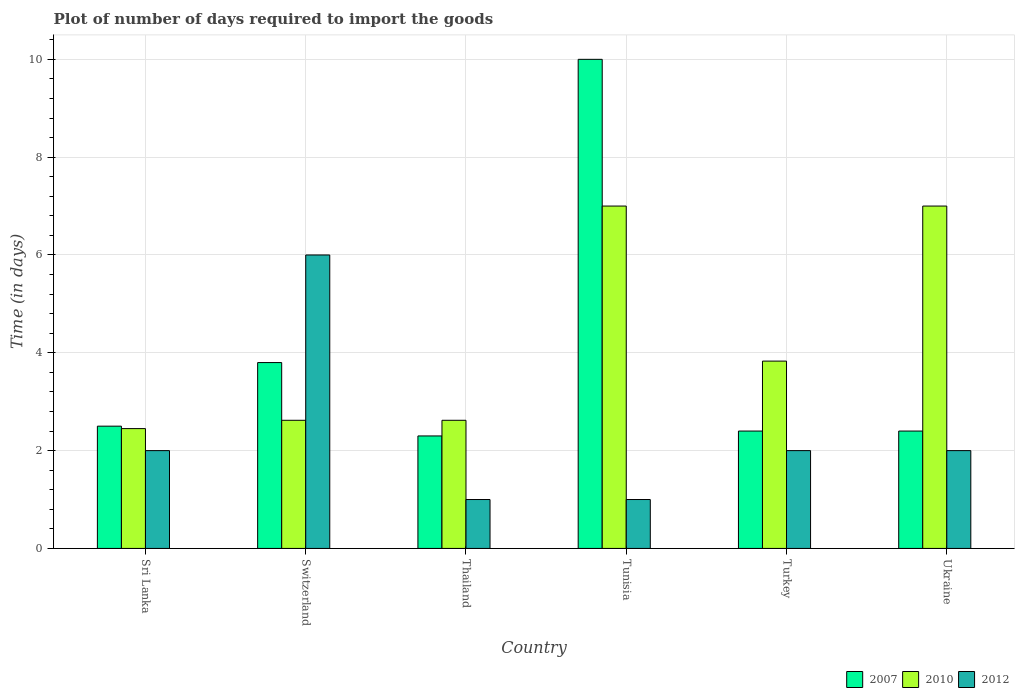How many groups of bars are there?
Provide a short and direct response. 6. Are the number of bars per tick equal to the number of legend labels?
Make the answer very short. Yes. Are the number of bars on each tick of the X-axis equal?
Provide a short and direct response. Yes. How many bars are there on the 3rd tick from the left?
Provide a succinct answer. 3. What is the label of the 6th group of bars from the left?
Make the answer very short. Ukraine. What is the time required to import goods in 2007 in Tunisia?
Your answer should be very brief. 10. Across all countries, what is the maximum time required to import goods in 2012?
Provide a short and direct response. 6. In which country was the time required to import goods in 2007 maximum?
Provide a short and direct response. Tunisia. In which country was the time required to import goods in 2012 minimum?
Give a very brief answer. Thailand. What is the total time required to import goods in 2007 in the graph?
Offer a very short reply. 23.4. What is the difference between the time required to import goods in 2010 in Sri Lanka and that in Tunisia?
Provide a short and direct response. -4.55. What is the difference between the time required to import goods in 2007 in Switzerland and the time required to import goods in 2010 in Thailand?
Provide a succinct answer. 1.18. What is the average time required to import goods in 2007 per country?
Keep it short and to the point. 3.9. What is the ratio of the time required to import goods in 2010 in Turkey to that in Ukraine?
Offer a very short reply. 0.55. Is the difference between the time required to import goods in 2012 in Sri Lanka and Thailand greater than the difference between the time required to import goods in 2007 in Sri Lanka and Thailand?
Give a very brief answer. Yes. What is the difference between the highest and the lowest time required to import goods in 2012?
Make the answer very short. 5. What does the 1st bar from the left in Tunisia represents?
Make the answer very short. 2007. What does the 2nd bar from the right in Thailand represents?
Your response must be concise. 2010. Is it the case that in every country, the sum of the time required to import goods in 2007 and time required to import goods in 2012 is greater than the time required to import goods in 2010?
Provide a short and direct response. No. How many bars are there?
Provide a short and direct response. 18. Are all the bars in the graph horizontal?
Your answer should be compact. No. How many countries are there in the graph?
Offer a terse response. 6. What is the difference between two consecutive major ticks on the Y-axis?
Provide a succinct answer. 2. Does the graph contain any zero values?
Your response must be concise. No. How many legend labels are there?
Your response must be concise. 3. What is the title of the graph?
Your answer should be very brief. Plot of number of days required to import the goods. Does "2006" appear as one of the legend labels in the graph?
Offer a very short reply. No. What is the label or title of the Y-axis?
Keep it short and to the point. Time (in days). What is the Time (in days) in 2007 in Sri Lanka?
Offer a terse response. 2.5. What is the Time (in days) in 2010 in Sri Lanka?
Give a very brief answer. 2.45. What is the Time (in days) in 2010 in Switzerland?
Offer a very short reply. 2.62. What is the Time (in days) in 2012 in Switzerland?
Make the answer very short. 6. What is the Time (in days) of 2007 in Thailand?
Give a very brief answer. 2.3. What is the Time (in days) of 2010 in Thailand?
Offer a very short reply. 2.62. What is the Time (in days) in 2012 in Tunisia?
Provide a short and direct response. 1. What is the Time (in days) in 2010 in Turkey?
Ensure brevity in your answer.  3.83. What is the Time (in days) of 2010 in Ukraine?
Offer a terse response. 7. What is the Time (in days) in 2012 in Ukraine?
Your response must be concise. 2. Across all countries, what is the maximum Time (in days) of 2007?
Offer a terse response. 10. Across all countries, what is the maximum Time (in days) of 2010?
Provide a succinct answer. 7. Across all countries, what is the minimum Time (in days) in 2010?
Your answer should be very brief. 2.45. Across all countries, what is the minimum Time (in days) in 2012?
Your answer should be compact. 1. What is the total Time (in days) of 2007 in the graph?
Ensure brevity in your answer.  23.4. What is the total Time (in days) of 2010 in the graph?
Your answer should be compact. 25.52. What is the difference between the Time (in days) of 2010 in Sri Lanka and that in Switzerland?
Make the answer very short. -0.17. What is the difference between the Time (in days) in 2012 in Sri Lanka and that in Switzerland?
Your response must be concise. -4. What is the difference between the Time (in days) in 2010 in Sri Lanka and that in Thailand?
Make the answer very short. -0.17. What is the difference between the Time (in days) in 2012 in Sri Lanka and that in Thailand?
Give a very brief answer. 1. What is the difference between the Time (in days) in 2010 in Sri Lanka and that in Tunisia?
Keep it short and to the point. -4.55. What is the difference between the Time (in days) in 2012 in Sri Lanka and that in Tunisia?
Make the answer very short. 1. What is the difference between the Time (in days) in 2010 in Sri Lanka and that in Turkey?
Ensure brevity in your answer.  -1.38. What is the difference between the Time (in days) in 2012 in Sri Lanka and that in Turkey?
Make the answer very short. 0. What is the difference between the Time (in days) of 2010 in Sri Lanka and that in Ukraine?
Provide a succinct answer. -4.55. What is the difference between the Time (in days) of 2007 in Switzerland and that in Thailand?
Make the answer very short. 1.5. What is the difference between the Time (in days) in 2010 in Switzerland and that in Thailand?
Make the answer very short. 0. What is the difference between the Time (in days) in 2010 in Switzerland and that in Tunisia?
Ensure brevity in your answer.  -4.38. What is the difference between the Time (in days) in 2012 in Switzerland and that in Tunisia?
Offer a very short reply. 5. What is the difference between the Time (in days) of 2007 in Switzerland and that in Turkey?
Your answer should be compact. 1.4. What is the difference between the Time (in days) in 2010 in Switzerland and that in Turkey?
Provide a short and direct response. -1.21. What is the difference between the Time (in days) in 2012 in Switzerland and that in Turkey?
Offer a very short reply. 4. What is the difference between the Time (in days) of 2007 in Switzerland and that in Ukraine?
Provide a succinct answer. 1.4. What is the difference between the Time (in days) in 2010 in Switzerland and that in Ukraine?
Make the answer very short. -4.38. What is the difference between the Time (in days) of 2012 in Switzerland and that in Ukraine?
Offer a terse response. 4. What is the difference between the Time (in days) in 2010 in Thailand and that in Tunisia?
Your answer should be compact. -4.38. What is the difference between the Time (in days) of 2012 in Thailand and that in Tunisia?
Make the answer very short. 0. What is the difference between the Time (in days) in 2010 in Thailand and that in Turkey?
Keep it short and to the point. -1.21. What is the difference between the Time (in days) in 2012 in Thailand and that in Turkey?
Offer a terse response. -1. What is the difference between the Time (in days) of 2010 in Thailand and that in Ukraine?
Make the answer very short. -4.38. What is the difference between the Time (in days) of 2012 in Thailand and that in Ukraine?
Provide a short and direct response. -1. What is the difference between the Time (in days) in 2007 in Tunisia and that in Turkey?
Make the answer very short. 7.6. What is the difference between the Time (in days) of 2010 in Tunisia and that in Turkey?
Provide a succinct answer. 3.17. What is the difference between the Time (in days) in 2012 in Tunisia and that in Turkey?
Keep it short and to the point. -1. What is the difference between the Time (in days) of 2007 in Tunisia and that in Ukraine?
Provide a short and direct response. 7.6. What is the difference between the Time (in days) of 2007 in Turkey and that in Ukraine?
Your response must be concise. 0. What is the difference between the Time (in days) in 2010 in Turkey and that in Ukraine?
Provide a succinct answer. -3.17. What is the difference between the Time (in days) in 2012 in Turkey and that in Ukraine?
Offer a terse response. 0. What is the difference between the Time (in days) of 2007 in Sri Lanka and the Time (in days) of 2010 in Switzerland?
Make the answer very short. -0.12. What is the difference between the Time (in days) of 2010 in Sri Lanka and the Time (in days) of 2012 in Switzerland?
Your response must be concise. -3.55. What is the difference between the Time (in days) in 2007 in Sri Lanka and the Time (in days) in 2010 in Thailand?
Provide a succinct answer. -0.12. What is the difference between the Time (in days) in 2007 in Sri Lanka and the Time (in days) in 2012 in Thailand?
Provide a short and direct response. 1.5. What is the difference between the Time (in days) in 2010 in Sri Lanka and the Time (in days) in 2012 in Thailand?
Make the answer very short. 1.45. What is the difference between the Time (in days) in 2007 in Sri Lanka and the Time (in days) in 2012 in Tunisia?
Your answer should be compact. 1.5. What is the difference between the Time (in days) in 2010 in Sri Lanka and the Time (in days) in 2012 in Tunisia?
Keep it short and to the point. 1.45. What is the difference between the Time (in days) in 2007 in Sri Lanka and the Time (in days) in 2010 in Turkey?
Your answer should be compact. -1.33. What is the difference between the Time (in days) of 2007 in Sri Lanka and the Time (in days) of 2012 in Turkey?
Your answer should be very brief. 0.5. What is the difference between the Time (in days) in 2010 in Sri Lanka and the Time (in days) in 2012 in Turkey?
Offer a terse response. 0.45. What is the difference between the Time (in days) of 2010 in Sri Lanka and the Time (in days) of 2012 in Ukraine?
Your answer should be compact. 0.45. What is the difference between the Time (in days) of 2007 in Switzerland and the Time (in days) of 2010 in Thailand?
Make the answer very short. 1.18. What is the difference between the Time (in days) in 2010 in Switzerland and the Time (in days) in 2012 in Thailand?
Keep it short and to the point. 1.62. What is the difference between the Time (in days) of 2007 in Switzerland and the Time (in days) of 2012 in Tunisia?
Offer a terse response. 2.8. What is the difference between the Time (in days) in 2010 in Switzerland and the Time (in days) in 2012 in Tunisia?
Give a very brief answer. 1.62. What is the difference between the Time (in days) of 2007 in Switzerland and the Time (in days) of 2010 in Turkey?
Provide a short and direct response. -0.03. What is the difference between the Time (in days) in 2007 in Switzerland and the Time (in days) in 2012 in Turkey?
Provide a short and direct response. 1.8. What is the difference between the Time (in days) of 2010 in Switzerland and the Time (in days) of 2012 in Turkey?
Offer a very short reply. 0.62. What is the difference between the Time (in days) in 2007 in Switzerland and the Time (in days) in 2010 in Ukraine?
Your answer should be compact. -3.2. What is the difference between the Time (in days) in 2007 in Switzerland and the Time (in days) in 2012 in Ukraine?
Offer a very short reply. 1.8. What is the difference between the Time (in days) of 2010 in Switzerland and the Time (in days) of 2012 in Ukraine?
Make the answer very short. 0.62. What is the difference between the Time (in days) in 2007 in Thailand and the Time (in days) in 2012 in Tunisia?
Offer a very short reply. 1.3. What is the difference between the Time (in days) of 2010 in Thailand and the Time (in days) of 2012 in Tunisia?
Provide a succinct answer. 1.62. What is the difference between the Time (in days) in 2007 in Thailand and the Time (in days) in 2010 in Turkey?
Give a very brief answer. -1.53. What is the difference between the Time (in days) in 2010 in Thailand and the Time (in days) in 2012 in Turkey?
Your response must be concise. 0.62. What is the difference between the Time (in days) in 2007 in Thailand and the Time (in days) in 2012 in Ukraine?
Make the answer very short. 0.3. What is the difference between the Time (in days) of 2010 in Thailand and the Time (in days) of 2012 in Ukraine?
Give a very brief answer. 0.62. What is the difference between the Time (in days) of 2007 in Tunisia and the Time (in days) of 2010 in Turkey?
Your response must be concise. 6.17. What is the difference between the Time (in days) of 2007 in Tunisia and the Time (in days) of 2012 in Turkey?
Offer a very short reply. 8. What is the difference between the Time (in days) in 2007 in Tunisia and the Time (in days) in 2010 in Ukraine?
Your answer should be very brief. 3. What is the difference between the Time (in days) in 2007 in Tunisia and the Time (in days) in 2012 in Ukraine?
Give a very brief answer. 8. What is the difference between the Time (in days) of 2010 in Tunisia and the Time (in days) of 2012 in Ukraine?
Keep it short and to the point. 5. What is the difference between the Time (in days) in 2007 in Turkey and the Time (in days) in 2010 in Ukraine?
Provide a succinct answer. -4.6. What is the difference between the Time (in days) in 2007 in Turkey and the Time (in days) in 2012 in Ukraine?
Your answer should be very brief. 0.4. What is the difference between the Time (in days) of 2010 in Turkey and the Time (in days) of 2012 in Ukraine?
Provide a short and direct response. 1.83. What is the average Time (in days) of 2010 per country?
Your response must be concise. 4.25. What is the average Time (in days) of 2012 per country?
Provide a short and direct response. 2.33. What is the difference between the Time (in days) in 2010 and Time (in days) in 2012 in Sri Lanka?
Ensure brevity in your answer.  0.45. What is the difference between the Time (in days) in 2007 and Time (in days) in 2010 in Switzerland?
Offer a very short reply. 1.18. What is the difference between the Time (in days) in 2010 and Time (in days) in 2012 in Switzerland?
Ensure brevity in your answer.  -3.38. What is the difference between the Time (in days) in 2007 and Time (in days) in 2010 in Thailand?
Make the answer very short. -0.32. What is the difference between the Time (in days) in 2007 and Time (in days) in 2012 in Thailand?
Your response must be concise. 1.3. What is the difference between the Time (in days) in 2010 and Time (in days) in 2012 in Thailand?
Offer a terse response. 1.62. What is the difference between the Time (in days) of 2010 and Time (in days) of 2012 in Tunisia?
Offer a terse response. 6. What is the difference between the Time (in days) in 2007 and Time (in days) in 2010 in Turkey?
Give a very brief answer. -1.43. What is the difference between the Time (in days) in 2010 and Time (in days) in 2012 in Turkey?
Your answer should be very brief. 1.83. What is the difference between the Time (in days) in 2007 and Time (in days) in 2010 in Ukraine?
Provide a succinct answer. -4.6. What is the ratio of the Time (in days) of 2007 in Sri Lanka to that in Switzerland?
Your answer should be very brief. 0.66. What is the ratio of the Time (in days) of 2010 in Sri Lanka to that in Switzerland?
Make the answer very short. 0.94. What is the ratio of the Time (in days) of 2012 in Sri Lanka to that in Switzerland?
Keep it short and to the point. 0.33. What is the ratio of the Time (in days) in 2007 in Sri Lanka to that in Thailand?
Offer a terse response. 1.09. What is the ratio of the Time (in days) in 2010 in Sri Lanka to that in Thailand?
Provide a short and direct response. 0.94. What is the ratio of the Time (in days) of 2012 in Sri Lanka to that in Thailand?
Provide a short and direct response. 2. What is the ratio of the Time (in days) of 2007 in Sri Lanka to that in Tunisia?
Provide a short and direct response. 0.25. What is the ratio of the Time (in days) in 2010 in Sri Lanka to that in Tunisia?
Keep it short and to the point. 0.35. What is the ratio of the Time (in days) in 2007 in Sri Lanka to that in Turkey?
Keep it short and to the point. 1.04. What is the ratio of the Time (in days) of 2010 in Sri Lanka to that in Turkey?
Your answer should be very brief. 0.64. What is the ratio of the Time (in days) of 2007 in Sri Lanka to that in Ukraine?
Provide a short and direct response. 1.04. What is the ratio of the Time (in days) of 2012 in Sri Lanka to that in Ukraine?
Ensure brevity in your answer.  1. What is the ratio of the Time (in days) of 2007 in Switzerland to that in Thailand?
Offer a terse response. 1.65. What is the ratio of the Time (in days) of 2010 in Switzerland to that in Thailand?
Give a very brief answer. 1. What is the ratio of the Time (in days) of 2012 in Switzerland to that in Thailand?
Give a very brief answer. 6. What is the ratio of the Time (in days) in 2007 in Switzerland to that in Tunisia?
Your answer should be compact. 0.38. What is the ratio of the Time (in days) of 2010 in Switzerland to that in Tunisia?
Offer a very short reply. 0.37. What is the ratio of the Time (in days) in 2012 in Switzerland to that in Tunisia?
Keep it short and to the point. 6. What is the ratio of the Time (in days) of 2007 in Switzerland to that in Turkey?
Provide a succinct answer. 1.58. What is the ratio of the Time (in days) of 2010 in Switzerland to that in Turkey?
Your answer should be very brief. 0.68. What is the ratio of the Time (in days) in 2012 in Switzerland to that in Turkey?
Your answer should be compact. 3. What is the ratio of the Time (in days) of 2007 in Switzerland to that in Ukraine?
Your answer should be compact. 1.58. What is the ratio of the Time (in days) of 2010 in Switzerland to that in Ukraine?
Your answer should be very brief. 0.37. What is the ratio of the Time (in days) of 2007 in Thailand to that in Tunisia?
Give a very brief answer. 0.23. What is the ratio of the Time (in days) in 2010 in Thailand to that in Tunisia?
Provide a short and direct response. 0.37. What is the ratio of the Time (in days) in 2012 in Thailand to that in Tunisia?
Your response must be concise. 1. What is the ratio of the Time (in days) of 2010 in Thailand to that in Turkey?
Offer a terse response. 0.68. What is the ratio of the Time (in days) of 2007 in Thailand to that in Ukraine?
Provide a succinct answer. 0.96. What is the ratio of the Time (in days) in 2010 in Thailand to that in Ukraine?
Make the answer very short. 0.37. What is the ratio of the Time (in days) in 2012 in Thailand to that in Ukraine?
Provide a succinct answer. 0.5. What is the ratio of the Time (in days) of 2007 in Tunisia to that in Turkey?
Offer a very short reply. 4.17. What is the ratio of the Time (in days) of 2010 in Tunisia to that in Turkey?
Your response must be concise. 1.83. What is the ratio of the Time (in days) of 2012 in Tunisia to that in Turkey?
Keep it short and to the point. 0.5. What is the ratio of the Time (in days) of 2007 in Tunisia to that in Ukraine?
Your answer should be compact. 4.17. What is the ratio of the Time (in days) of 2007 in Turkey to that in Ukraine?
Your response must be concise. 1. What is the ratio of the Time (in days) of 2010 in Turkey to that in Ukraine?
Offer a terse response. 0.55. What is the ratio of the Time (in days) in 2012 in Turkey to that in Ukraine?
Your answer should be very brief. 1. What is the difference between the highest and the second highest Time (in days) of 2007?
Ensure brevity in your answer.  6.2. What is the difference between the highest and the second highest Time (in days) of 2010?
Make the answer very short. 0. What is the difference between the highest and the lowest Time (in days) of 2007?
Ensure brevity in your answer.  7.7. What is the difference between the highest and the lowest Time (in days) in 2010?
Make the answer very short. 4.55. What is the difference between the highest and the lowest Time (in days) of 2012?
Provide a succinct answer. 5. 